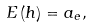Convert formula to latex. <formula><loc_0><loc_0><loc_500><loc_500>E \left ( h \right ) = a _ { e } ,</formula> 